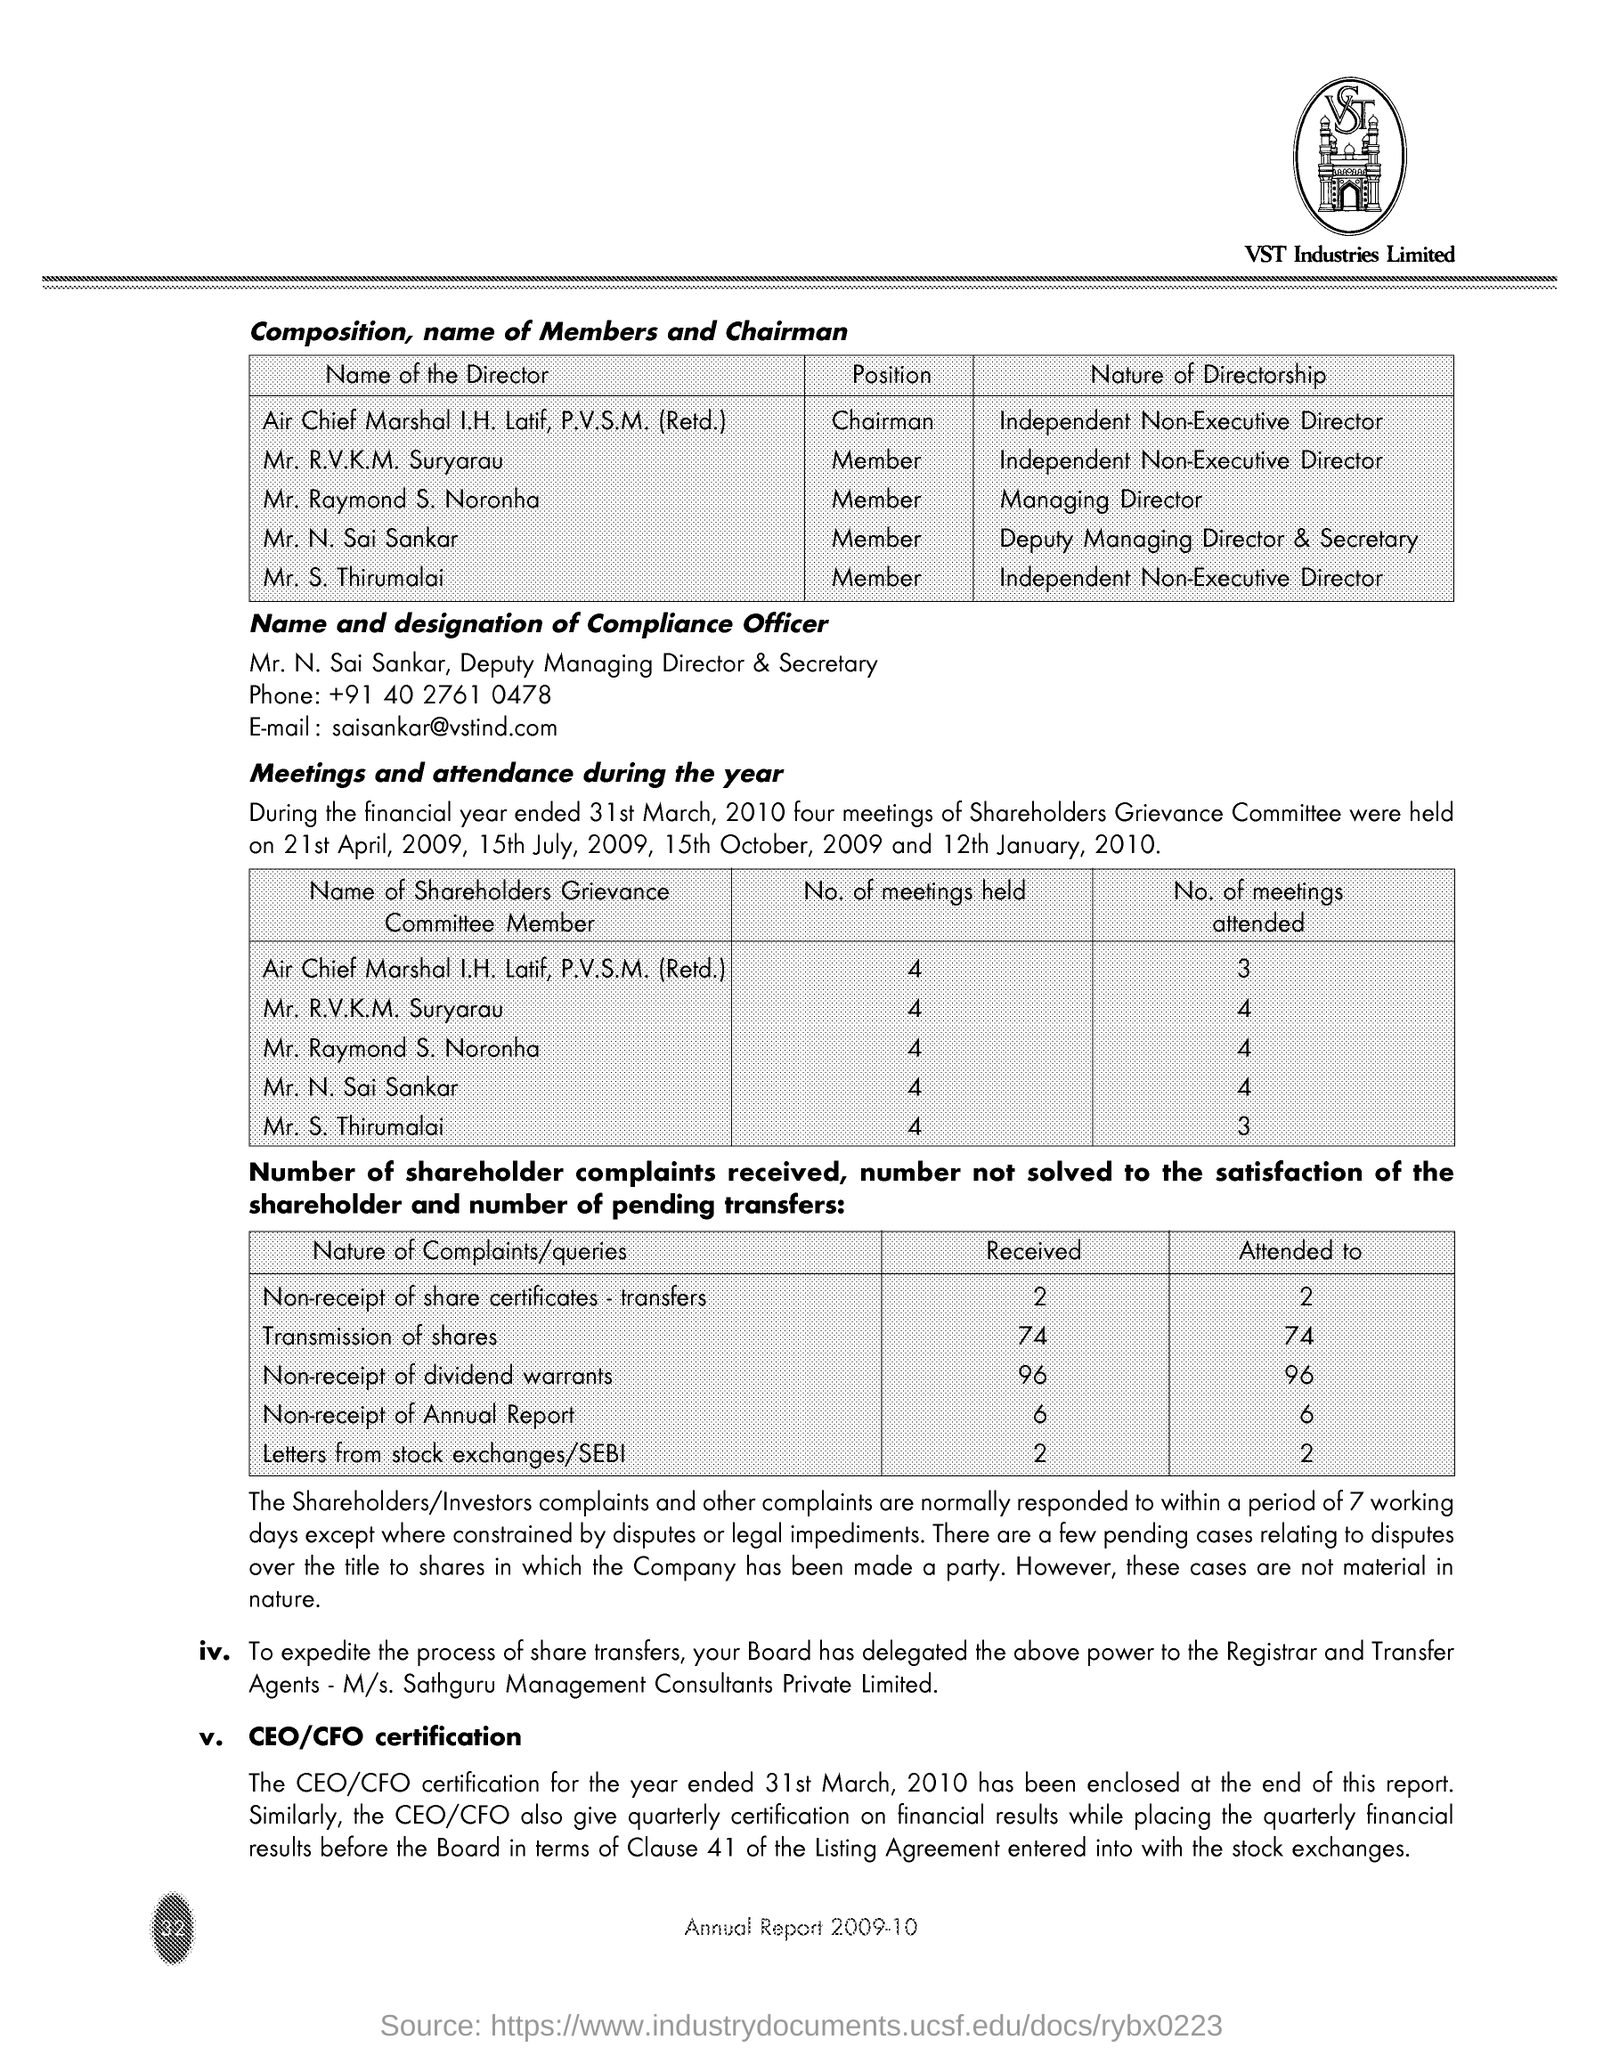What is the name of Compliance officer?
Make the answer very short. Mr. N. Sai Sankar. What is the designation of Mr. N. Sai Sankar?
Make the answer very short. Deputy Managing Director & Secretary. How many Shareholders Grievance Committe Meetings were attended by Mr. S. Thirumalai during the financial year ended 31st March, 2010?
Your answer should be compact. 3. How many complaints on Transmission of Shares are received from the shareholders?
Give a very brief answer. 74. How many complaints on Non-receipt of Annual Report are received from the shareholders?
Offer a very short reply. 6. How many Shareholders Grievance Committe Meetings were attended by Mr. N. Sai Sankar during the financial year ended 31st March, 2010?
Provide a short and direct response. 4. What is the Nature of Directorship of Mr. S. Thirumalai?
Ensure brevity in your answer.  Independent Non-Executive Director. What is the Nature of Directorship of Mr. Raymond S. Noronha?
Ensure brevity in your answer.  Managing Director. 